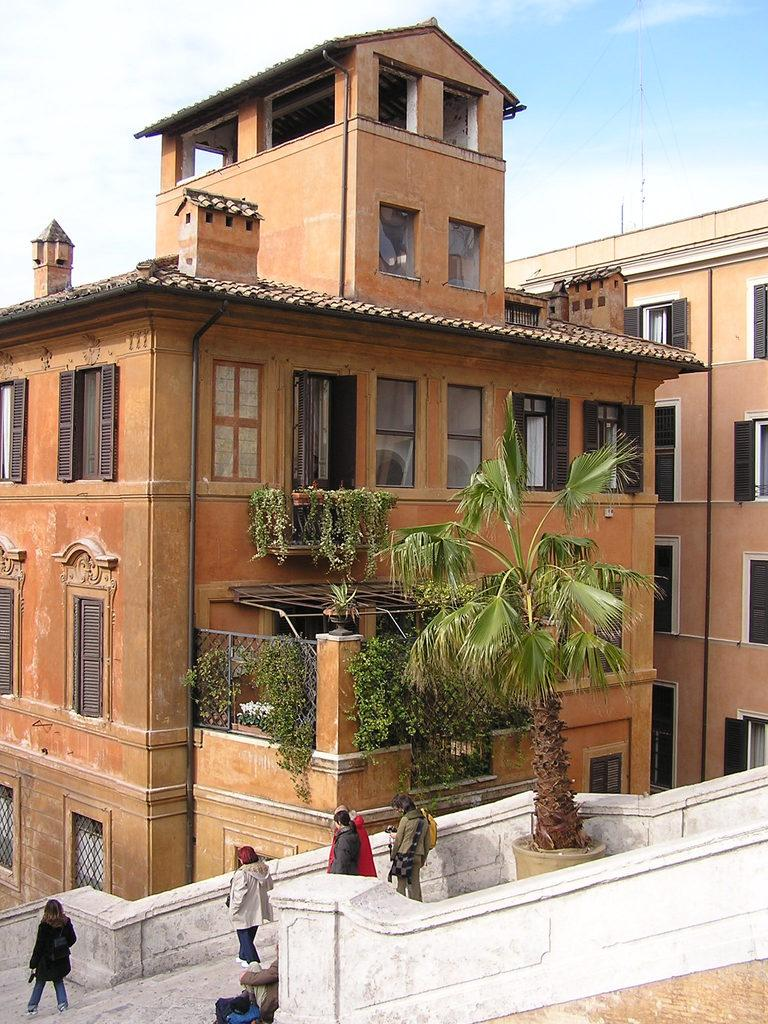Who or what can be seen in the image? There are people in the image. What is an unusual feature of the tree in the image? The tree is on the stairs. What type of structures are visible in the image? There are buildings in the image. What type of vegetation is growing on the buildings? Creeper plants are present on the buildings. What can be seen in the distance in the image? The sky is visible in the background of the image. What time of day is it in the image, and how can you tell? The time of day cannot be determined from the image, as there are no clues such as shadows or lighting to indicate the hour. 